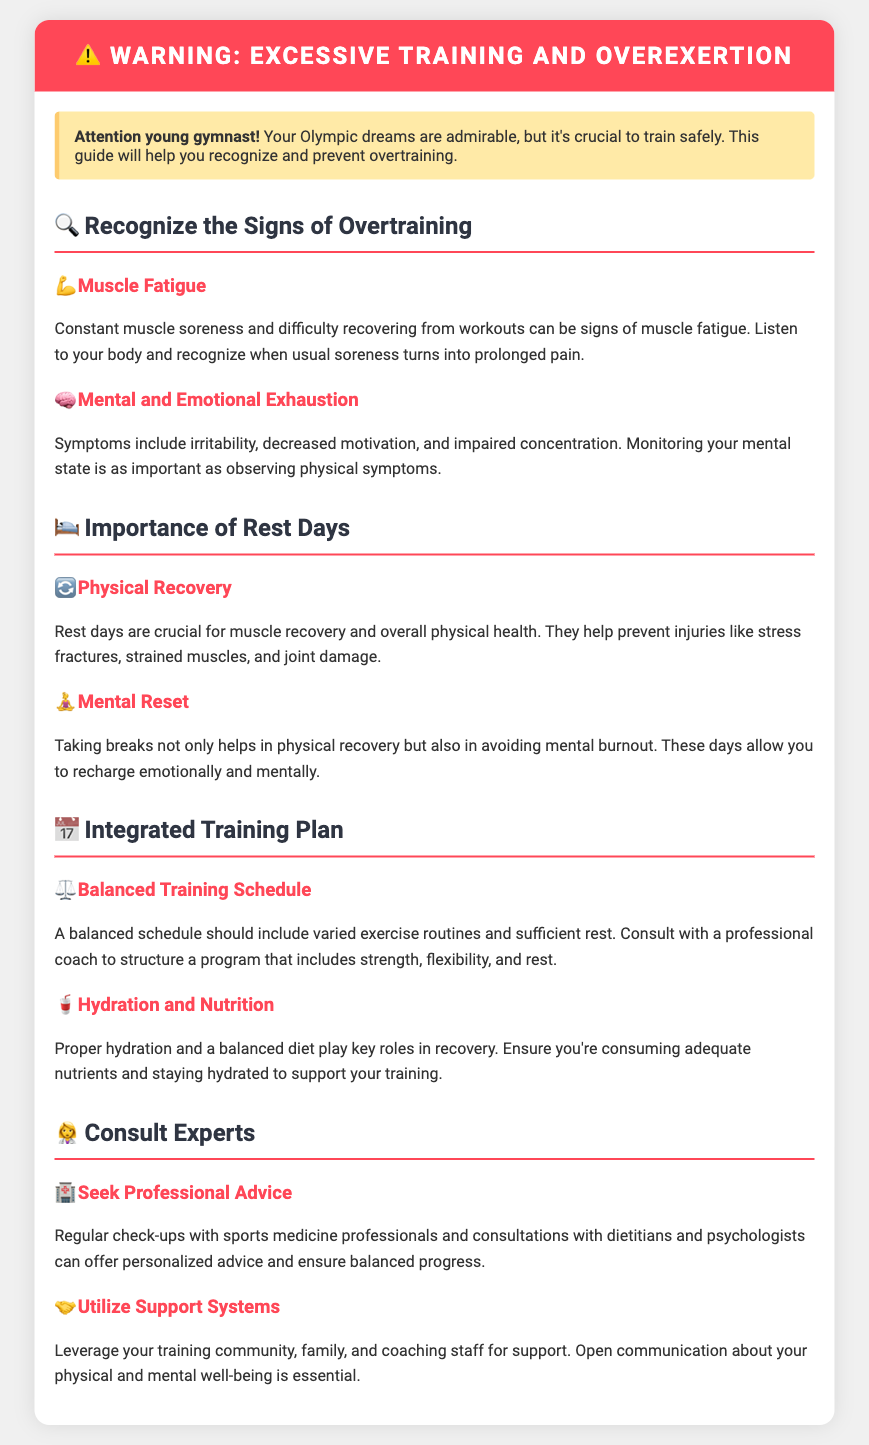What is the title of the document? The title of the document is indicated by the `<title>` tag in the header section.
Answer: Gymnast Training Warning What symptom indicates muscle fatigue? The document states that "constant muscle soreness and difficulty recovering from workouts" are signs of muscle fatigue.
Answer: Muscle soreness What should be included in a balanced training schedule? The document suggests that a balanced schedule should have "varied exercise routines and sufficient rest."
Answer: Varied exercise What is one sign of mental exhaustion? The document lists "irritability" as a symptom of mental exhaustion.
Answer: Irritability How are rest days beneficial? The document explains that rest days are crucial for "muscle recovery and overall physical health."
Answer: Muscle recovery What two aspects do rest days help with? The document states that rest days help with "physical recovery" and "mental reset."
Answer: Physical recovery and mental reset Who should you consult for personalized advice? The document advises seeking regular check-ups with "sports medicine professionals."
Answer: Sports medicine professionals What should you leverage for support? The document suggests leveraging your "training community, family, and coaching staff."
Answer: Training community What role do proper hydration and nutrition play? The document highlights that they play key roles in "recovery."
Answer: Recovery 